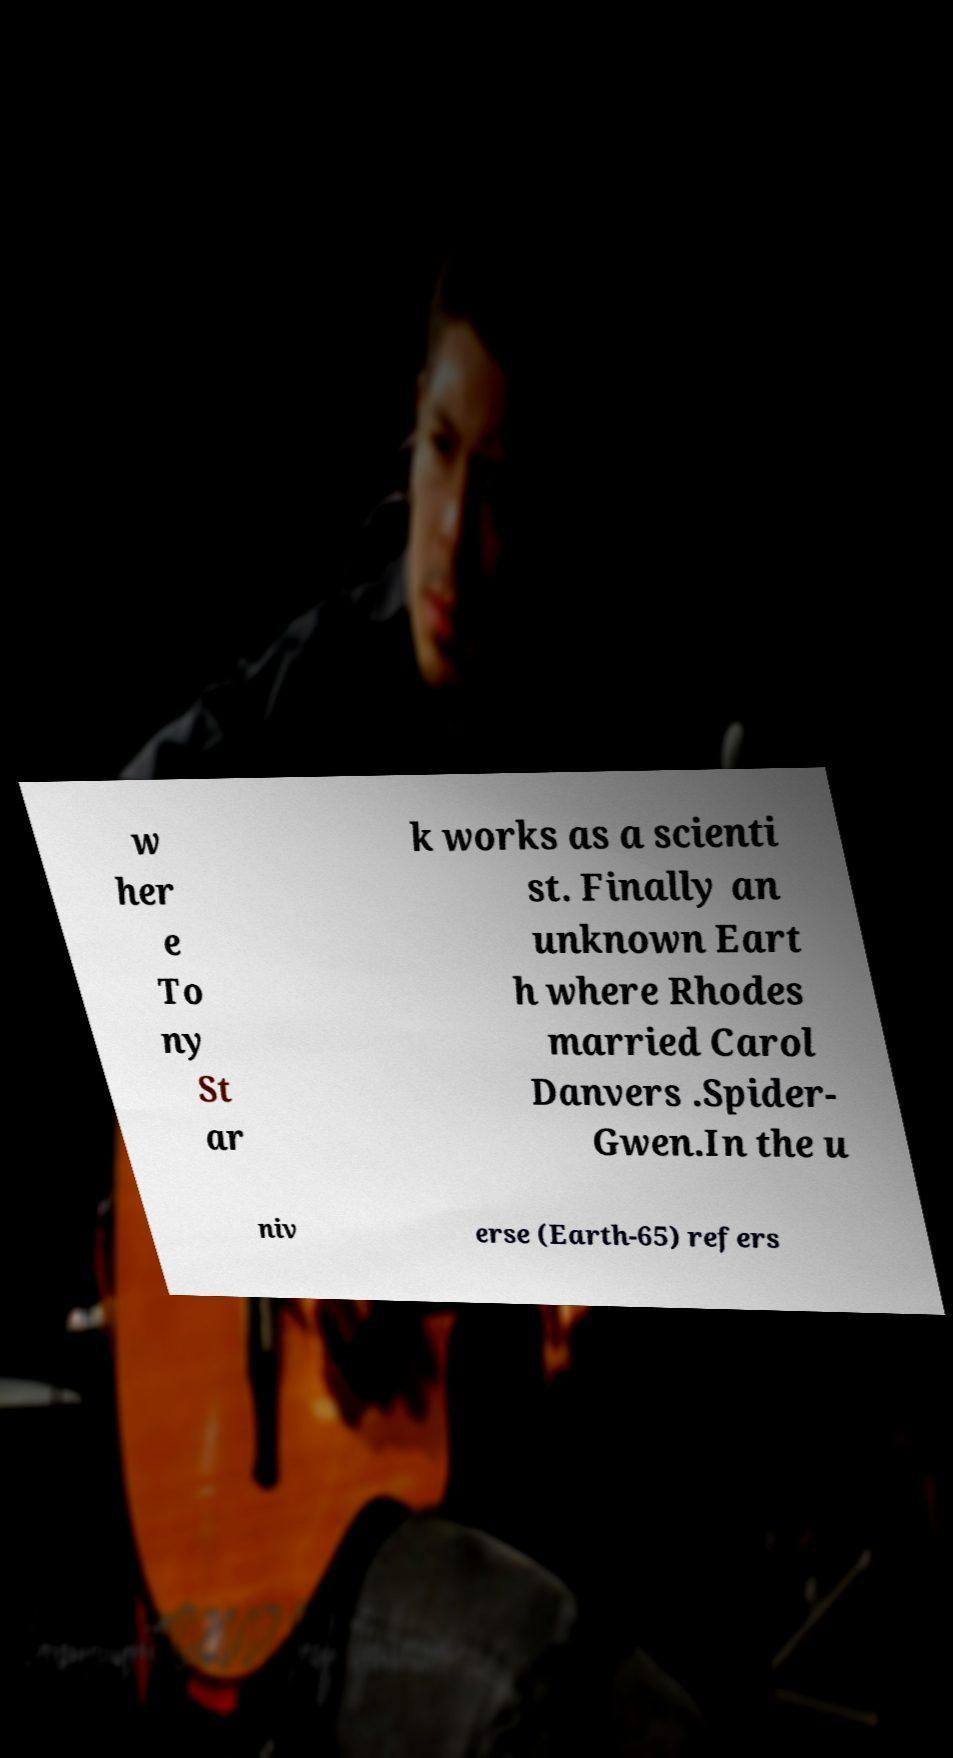For documentation purposes, I need the text within this image transcribed. Could you provide that? w her e To ny St ar k works as a scienti st. Finally an unknown Eart h where Rhodes married Carol Danvers .Spider- Gwen.In the u niv erse (Earth-65) refers 